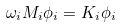Convert formula to latex. <formula><loc_0><loc_0><loc_500><loc_500>\omega _ { i } M _ { i } \phi _ { i } = K _ { i } \phi _ { i }</formula> 